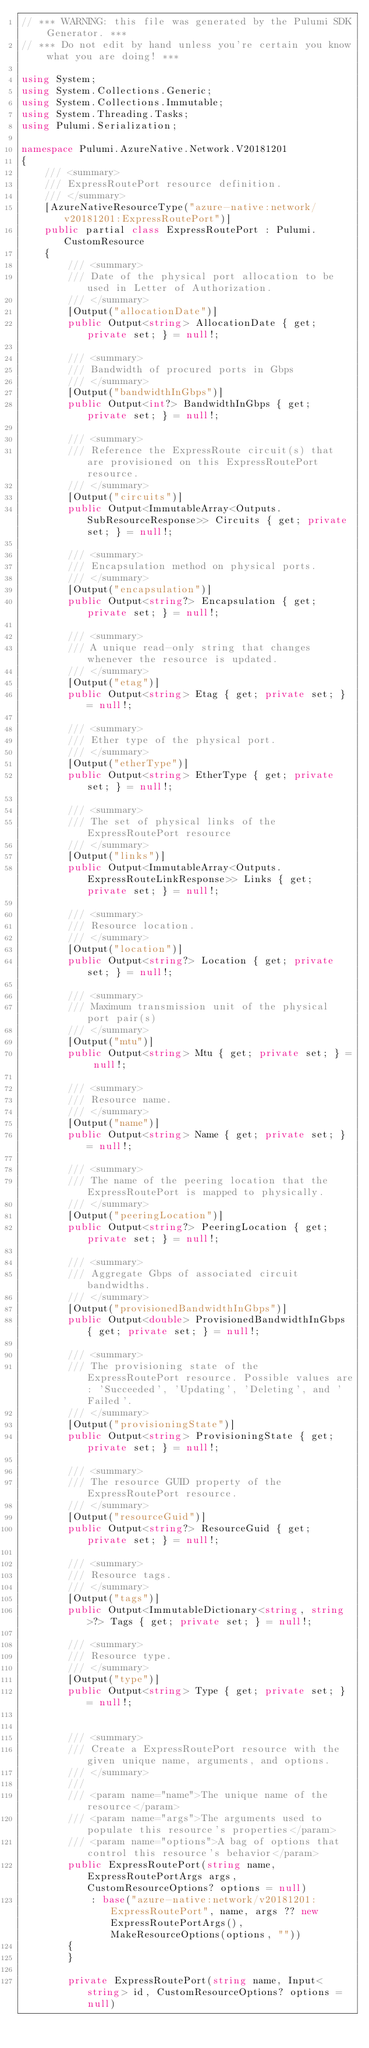Convert code to text. <code><loc_0><loc_0><loc_500><loc_500><_C#_>// *** WARNING: this file was generated by the Pulumi SDK Generator. ***
// *** Do not edit by hand unless you're certain you know what you are doing! ***

using System;
using System.Collections.Generic;
using System.Collections.Immutable;
using System.Threading.Tasks;
using Pulumi.Serialization;

namespace Pulumi.AzureNative.Network.V20181201
{
    /// <summary>
    /// ExpressRoutePort resource definition.
    /// </summary>
    [AzureNativeResourceType("azure-native:network/v20181201:ExpressRoutePort")]
    public partial class ExpressRoutePort : Pulumi.CustomResource
    {
        /// <summary>
        /// Date of the physical port allocation to be used in Letter of Authorization.
        /// </summary>
        [Output("allocationDate")]
        public Output<string> AllocationDate { get; private set; } = null!;

        /// <summary>
        /// Bandwidth of procured ports in Gbps
        /// </summary>
        [Output("bandwidthInGbps")]
        public Output<int?> BandwidthInGbps { get; private set; } = null!;

        /// <summary>
        /// Reference the ExpressRoute circuit(s) that are provisioned on this ExpressRoutePort resource.
        /// </summary>
        [Output("circuits")]
        public Output<ImmutableArray<Outputs.SubResourceResponse>> Circuits { get; private set; } = null!;

        /// <summary>
        /// Encapsulation method on physical ports.
        /// </summary>
        [Output("encapsulation")]
        public Output<string?> Encapsulation { get; private set; } = null!;

        /// <summary>
        /// A unique read-only string that changes whenever the resource is updated.
        /// </summary>
        [Output("etag")]
        public Output<string> Etag { get; private set; } = null!;

        /// <summary>
        /// Ether type of the physical port.
        /// </summary>
        [Output("etherType")]
        public Output<string> EtherType { get; private set; } = null!;

        /// <summary>
        /// The set of physical links of the ExpressRoutePort resource
        /// </summary>
        [Output("links")]
        public Output<ImmutableArray<Outputs.ExpressRouteLinkResponse>> Links { get; private set; } = null!;

        /// <summary>
        /// Resource location.
        /// </summary>
        [Output("location")]
        public Output<string?> Location { get; private set; } = null!;

        /// <summary>
        /// Maximum transmission unit of the physical port pair(s)
        /// </summary>
        [Output("mtu")]
        public Output<string> Mtu { get; private set; } = null!;

        /// <summary>
        /// Resource name.
        /// </summary>
        [Output("name")]
        public Output<string> Name { get; private set; } = null!;

        /// <summary>
        /// The name of the peering location that the ExpressRoutePort is mapped to physically.
        /// </summary>
        [Output("peeringLocation")]
        public Output<string?> PeeringLocation { get; private set; } = null!;

        /// <summary>
        /// Aggregate Gbps of associated circuit bandwidths.
        /// </summary>
        [Output("provisionedBandwidthInGbps")]
        public Output<double> ProvisionedBandwidthInGbps { get; private set; } = null!;

        /// <summary>
        /// The provisioning state of the ExpressRoutePort resource. Possible values are: 'Succeeded', 'Updating', 'Deleting', and 'Failed'.
        /// </summary>
        [Output("provisioningState")]
        public Output<string> ProvisioningState { get; private set; } = null!;

        /// <summary>
        /// The resource GUID property of the ExpressRoutePort resource.
        /// </summary>
        [Output("resourceGuid")]
        public Output<string?> ResourceGuid { get; private set; } = null!;

        /// <summary>
        /// Resource tags.
        /// </summary>
        [Output("tags")]
        public Output<ImmutableDictionary<string, string>?> Tags { get; private set; } = null!;

        /// <summary>
        /// Resource type.
        /// </summary>
        [Output("type")]
        public Output<string> Type { get; private set; } = null!;


        /// <summary>
        /// Create a ExpressRoutePort resource with the given unique name, arguments, and options.
        /// </summary>
        ///
        /// <param name="name">The unique name of the resource</param>
        /// <param name="args">The arguments used to populate this resource's properties</param>
        /// <param name="options">A bag of options that control this resource's behavior</param>
        public ExpressRoutePort(string name, ExpressRoutePortArgs args, CustomResourceOptions? options = null)
            : base("azure-native:network/v20181201:ExpressRoutePort", name, args ?? new ExpressRoutePortArgs(), MakeResourceOptions(options, ""))
        {
        }

        private ExpressRoutePort(string name, Input<string> id, CustomResourceOptions? options = null)</code> 